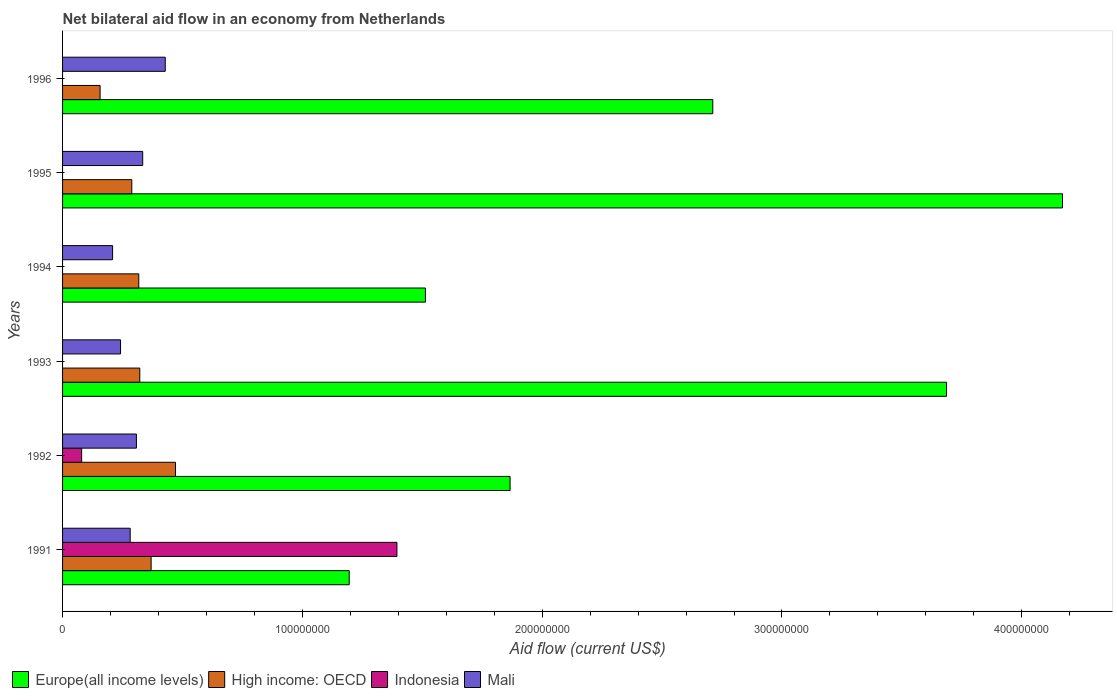How many different coloured bars are there?
Make the answer very short. 4. Are the number of bars per tick equal to the number of legend labels?
Give a very brief answer. No. Are the number of bars on each tick of the Y-axis equal?
Give a very brief answer. No. What is the net bilateral aid flow in Mali in 1992?
Offer a very short reply. 3.08e+07. Across all years, what is the maximum net bilateral aid flow in Europe(all income levels)?
Offer a very short reply. 4.17e+08. In which year was the net bilateral aid flow in Mali maximum?
Give a very brief answer. 1996. What is the total net bilateral aid flow in Mali in the graph?
Provide a short and direct response. 1.80e+08. What is the difference between the net bilateral aid flow in High income: OECD in 1992 and that in 1994?
Offer a terse response. 1.53e+07. What is the difference between the net bilateral aid flow in Mali in 1992 and the net bilateral aid flow in Europe(all income levels) in 1991?
Ensure brevity in your answer.  -8.87e+07. What is the average net bilateral aid flow in Indonesia per year?
Offer a terse response. 2.46e+07. In the year 1996, what is the difference between the net bilateral aid flow in High income: OECD and net bilateral aid flow in Europe(all income levels)?
Give a very brief answer. -2.56e+08. In how many years, is the net bilateral aid flow in Europe(all income levels) greater than 180000000 US$?
Provide a short and direct response. 4. What is the ratio of the net bilateral aid flow in Mali in 1991 to that in 1996?
Keep it short and to the point. 0.66. Is the difference between the net bilateral aid flow in High income: OECD in 1995 and 1996 greater than the difference between the net bilateral aid flow in Europe(all income levels) in 1995 and 1996?
Your answer should be compact. No. What is the difference between the highest and the second highest net bilateral aid flow in Europe(all income levels)?
Make the answer very short. 4.84e+07. What is the difference between the highest and the lowest net bilateral aid flow in High income: OECD?
Make the answer very short. 3.14e+07. In how many years, is the net bilateral aid flow in Indonesia greater than the average net bilateral aid flow in Indonesia taken over all years?
Make the answer very short. 1. Is the sum of the net bilateral aid flow in High income: OECD in 1991 and 1992 greater than the maximum net bilateral aid flow in Europe(all income levels) across all years?
Ensure brevity in your answer.  No. Is it the case that in every year, the sum of the net bilateral aid flow in Indonesia and net bilateral aid flow in Mali is greater than the net bilateral aid flow in High income: OECD?
Your answer should be very brief. No. How many bars are there?
Offer a terse response. 20. Are all the bars in the graph horizontal?
Your response must be concise. Yes. Does the graph contain grids?
Your answer should be compact. No. How many legend labels are there?
Make the answer very short. 4. What is the title of the graph?
Provide a short and direct response. Net bilateral aid flow in an economy from Netherlands. What is the label or title of the X-axis?
Your answer should be very brief. Aid flow (current US$). What is the Aid flow (current US$) in Europe(all income levels) in 1991?
Ensure brevity in your answer.  1.20e+08. What is the Aid flow (current US$) of High income: OECD in 1991?
Your response must be concise. 3.69e+07. What is the Aid flow (current US$) in Indonesia in 1991?
Offer a very short reply. 1.39e+08. What is the Aid flow (current US$) in Mali in 1991?
Give a very brief answer. 2.82e+07. What is the Aid flow (current US$) in Europe(all income levels) in 1992?
Offer a very short reply. 1.87e+08. What is the Aid flow (current US$) of High income: OECD in 1992?
Provide a succinct answer. 4.71e+07. What is the Aid flow (current US$) in Indonesia in 1992?
Your answer should be compact. 7.96e+06. What is the Aid flow (current US$) of Mali in 1992?
Your answer should be very brief. 3.08e+07. What is the Aid flow (current US$) in Europe(all income levels) in 1993?
Offer a terse response. 3.69e+08. What is the Aid flow (current US$) of High income: OECD in 1993?
Give a very brief answer. 3.22e+07. What is the Aid flow (current US$) in Mali in 1993?
Ensure brevity in your answer.  2.42e+07. What is the Aid flow (current US$) of Europe(all income levels) in 1994?
Provide a short and direct response. 1.51e+08. What is the Aid flow (current US$) of High income: OECD in 1994?
Ensure brevity in your answer.  3.18e+07. What is the Aid flow (current US$) in Indonesia in 1994?
Give a very brief answer. 0. What is the Aid flow (current US$) of Mali in 1994?
Offer a very short reply. 2.09e+07. What is the Aid flow (current US$) of Europe(all income levels) in 1995?
Provide a short and direct response. 4.17e+08. What is the Aid flow (current US$) in High income: OECD in 1995?
Provide a succinct answer. 2.89e+07. What is the Aid flow (current US$) of Indonesia in 1995?
Give a very brief answer. 0. What is the Aid flow (current US$) in Mali in 1995?
Provide a succinct answer. 3.34e+07. What is the Aid flow (current US$) in Europe(all income levels) in 1996?
Your answer should be compact. 2.71e+08. What is the Aid flow (current US$) in High income: OECD in 1996?
Your answer should be compact. 1.56e+07. What is the Aid flow (current US$) of Indonesia in 1996?
Your response must be concise. 0. What is the Aid flow (current US$) of Mali in 1996?
Your answer should be very brief. 4.28e+07. Across all years, what is the maximum Aid flow (current US$) of Europe(all income levels)?
Offer a very short reply. 4.17e+08. Across all years, what is the maximum Aid flow (current US$) of High income: OECD?
Make the answer very short. 4.71e+07. Across all years, what is the maximum Aid flow (current US$) in Indonesia?
Your response must be concise. 1.39e+08. Across all years, what is the maximum Aid flow (current US$) in Mali?
Keep it short and to the point. 4.28e+07. Across all years, what is the minimum Aid flow (current US$) in Europe(all income levels)?
Provide a short and direct response. 1.20e+08. Across all years, what is the minimum Aid flow (current US$) in High income: OECD?
Give a very brief answer. 1.56e+07. Across all years, what is the minimum Aid flow (current US$) in Indonesia?
Keep it short and to the point. 0. Across all years, what is the minimum Aid flow (current US$) of Mali?
Your answer should be compact. 2.09e+07. What is the total Aid flow (current US$) in Europe(all income levels) in the graph?
Your response must be concise. 1.51e+09. What is the total Aid flow (current US$) in High income: OECD in the graph?
Keep it short and to the point. 1.93e+08. What is the total Aid flow (current US$) in Indonesia in the graph?
Provide a succinct answer. 1.47e+08. What is the total Aid flow (current US$) in Mali in the graph?
Give a very brief answer. 1.80e+08. What is the difference between the Aid flow (current US$) in Europe(all income levels) in 1991 and that in 1992?
Give a very brief answer. -6.71e+07. What is the difference between the Aid flow (current US$) in High income: OECD in 1991 and that in 1992?
Your answer should be very brief. -1.02e+07. What is the difference between the Aid flow (current US$) of Indonesia in 1991 and that in 1992?
Give a very brief answer. 1.31e+08. What is the difference between the Aid flow (current US$) of Mali in 1991 and that in 1992?
Your answer should be compact. -2.60e+06. What is the difference between the Aid flow (current US$) of Europe(all income levels) in 1991 and that in 1993?
Your response must be concise. -2.49e+08. What is the difference between the Aid flow (current US$) of High income: OECD in 1991 and that in 1993?
Keep it short and to the point. 4.72e+06. What is the difference between the Aid flow (current US$) of Mali in 1991 and that in 1993?
Offer a terse response. 4.02e+06. What is the difference between the Aid flow (current US$) of Europe(all income levels) in 1991 and that in 1994?
Your response must be concise. -3.18e+07. What is the difference between the Aid flow (current US$) of High income: OECD in 1991 and that in 1994?
Keep it short and to the point. 5.15e+06. What is the difference between the Aid flow (current US$) of Mali in 1991 and that in 1994?
Provide a short and direct response. 7.34e+06. What is the difference between the Aid flow (current US$) in Europe(all income levels) in 1991 and that in 1995?
Your answer should be compact. -2.97e+08. What is the difference between the Aid flow (current US$) in High income: OECD in 1991 and that in 1995?
Provide a short and direct response. 8.06e+06. What is the difference between the Aid flow (current US$) of Mali in 1991 and that in 1995?
Give a very brief answer. -5.22e+06. What is the difference between the Aid flow (current US$) in Europe(all income levels) in 1991 and that in 1996?
Provide a succinct answer. -1.52e+08. What is the difference between the Aid flow (current US$) of High income: OECD in 1991 and that in 1996?
Ensure brevity in your answer.  2.13e+07. What is the difference between the Aid flow (current US$) in Mali in 1991 and that in 1996?
Offer a very short reply. -1.46e+07. What is the difference between the Aid flow (current US$) of Europe(all income levels) in 1992 and that in 1993?
Your answer should be compact. -1.82e+08. What is the difference between the Aid flow (current US$) in High income: OECD in 1992 and that in 1993?
Offer a very short reply. 1.49e+07. What is the difference between the Aid flow (current US$) of Mali in 1992 and that in 1993?
Make the answer very short. 6.62e+06. What is the difference between the Aid flow (current US$) in Europe(all income levels) in 1992 and that in 1994?
Your answer should be compact. 3.53e+07. What is the difference between the Aid flow (current US$) in High income: OECD in 1992 and that in 1994?
Ensure brevity in your answer.  1.53e+07. What is the difference between the Aid flow (current US$) of Mali in 1992 and that in 1994?
Your answer should be very brief. 9.94e+06. What is the difference between the Aid flow (current US$) of Europe(all income levels) in 1992 and that in 1995?
Your answer should be compact. -2.30e+08. What is the difference between the Aid flow (current US$) in High income: OECD in 1992 and that in 1995?
Offer a very short reply. 1.82e+07. What is the difference between the Aid flow (current US$) in Mali in 1992 and that in 1995?
Ensure brevity in your answer.  -2.62e+06. What is the difference between the Aid flow (current US$) in Europe(all income levels) in 1992 and that in 1996?
Provide a short and direct response. -8.45e+07. What is the difference between the Aid flow (current US$) of High income: OECD in 1992 and that in 1996?
Ensure brevity in your answer.  3.14e+07. What is the difference between the Aid flow (current US$) in Mali in 1992 and that in 1996?
Provide a succinct answer. -1.20e+07. What is the difference between the Aid flow (current US$) in Europe(all income levels) in 1993 and that in 1994?
Offer a very short reply. 2.17e+08. What is the difference between the Aid flow (current US$) in High income: OECD in 1993 and that in 1994?
Offer a very short reply. 4.30e+05. What is the difference between the Aid flow (current US$) of Mali in 1993 and that in 1994?
Your answer should be compact. 3.32e+06. What is the difference between the Aid flow (current US$) in Europe(all income levels) in 1993 and that in 1995?
Your answer should be compact. -4.84e+07. What is the difference between the Aid flow (current US$) of High income: OECD in 1993 and that in 1995?
Your answer should be very brief. 3.34e+06. What is the difference between the Aid flow (current US$) of Mali in 1993 and that in 1995?
Provide a succinct answer. -9.24e+06. What is the difference between the Aid flow (current US$) in Europe(all income levels) in 1993 and that in 1996?
Your response must be concise. 9.75e+07. What is the difference between the Aid flow (current US$) in High income: OECD in 1993 and that in 1996?
Your answer should be very brief. 1.66e+07. What is the difference between the Aid flow (current US$) in Mali in 1993 and that in 1996?
Make the answer very short. -1.86e+07. What is the difference between the Aid flow (current US$) in Europe(all income levels) in 1994 and that in 1995?
Offer a very short reply. -2.66e+08. What is the difference between the Aid flow (current US$) in High income: OECD in 1994 and that in 1995?
Provide a short and direct response. 2.91e+06. What is the difference between the Aid flow (current US$) in Mali in 1994 and that in 1995?
Give a very brief answer. -1.26e+07. What is the difference between the Aid flow (current US$) of Europe(all income levels) in 1994 and that in 1996?
Ensure brevity in your answer.  -1.20e+08. What is the difference between the Aid flow (current US$) of High income: OECD in 1994 and that in 1996?
Provide a short and direct response. 1.61e+07. What is the difference between the Aid flow (current US$) of Mali in 1994 and that in 1996?
Make the answer very short. -2.20e+07. What is the difference between the Aid flow (current US$) in Europe(all income levels) in 1995 and that in 1996?
Provide a succinct answer. 1.46e+08. What is the difference between the Aid flow (current US$) of High income: OECD in 1995 and that in 1996?
Give a very brief answer. 1.32e+07. What is the difference between the Aid flow (current US$) in Mali in 1995 and that in 1996?
Your answer should be very brief. -9.40e+06. What is the difference between the Aid flow (current US$) of Europe(all income levels) in 1991 and the Aid flow (current US$) of High income: OECD in 1992?
Keep it short and to the point. 7.24e+07. What is the difference between the Aid flow (current US$) of Europe(all income levels) in 1991 and the Aid flow (current US$) of Indonesia in 1992?
Provide a short and direct response. 1.12e+08. What is the difference between the Aid flow (current US$) in Europe(all income levels) in 1991 and the Aid flow (current US$) in Mali in 1992?
Your answer should be very brief. 8.87e+07. What is the difference between the Aid flow (current US$) of High income: OECD in 1991 and the Aid flow (current US$) of Indonesia in 1992?
Provide a short and direct response. 2.90e+07. What is the difference between the Aid flow (current US$) of High income: OECD in 1991 and the Aid flow (current US$) of Mali in 1992?
Make the answer very short. 6.13e+06. What is the difference between the Aid flow (current US$) in Indonesia in 1991 and the Aid flow (current US$) in Mali in 1992?
Provide a succinct answer. 1.09e+08. What is the difference between the Aid flow (current US$) in Europe(all income levels) in 1991 and the Aid flow (current US$) in High income: OECD in 1993?
Make the answer very short. 8.73e+07. What is the difference between the Aid flow (current US$) in Europe(all income levels) in 1991 and the Aid flow (current US$) in Mali in 1993?
Make the answer very short. 9.54e+07. What is the difference between the Aid flow (current US$) of High income: OECD in 1991 and the Aid flow (current US$) of Mali in 1993?
Provide a succinct answer. 1.28e+07. What is the difference between the Aid flow (current US$) of Indonesia in 1991 and the Aid flow (current US$) of Mali in 1993?
Make the answer very short. 1.15e+08. What is the difference between the Aid flow (current US$) in Europe(all income levels) in 1991 and the Aid flow (current US$) in High income: OECD in 1994?
Provide a short and direct response. 8.78e+07. What is the difference between the Aid flow (current US$) of Europe(all income levels) in 1991 and the Aid flow (current US$) of Mali in 1994?
Provide a short and direct response. 9.87e+07. What is the difference between the Aid flow (current US$) of High income: OECD in 1991 and the Aid flow (current US$) of Mali in 1994?
Offer a very short reply. 1.61e+07. What is the difference between the Aid flow (current US$) in Indonesia in 1991 and the Aid flow (current US$) in Mali in 1994?
Your answer should be compact. 1.19e+08. What is the difference between the Aid flow (current US$) of Europe(all income levels) in 1991 and the Aid flow (current US$) of High income: OECD in 1995?
Keep it short and to the point. 9.07e+07. What is the difference between the Aid flow (current US$) in Europe(all income levels) in 1991 and the Aid flow (current US$) in Mali in 1995?
Offer a terse response. 8.61e+07. What is the difference between the Aid flow (current US$) in High income: OECD in 1991 and the Aid flow (current US$) in Mali in 1995?
Make the answer very short. 3.51e+06. What is the difference between the Aid flow (current US$) of Indonesia in 1991 and the Aid flow (current US$) of Mali in 1995?
Your response must be concise. 1.06e+08. What is the difference between the Aid flow (current US$) in Europe(all income levels) in 1991 and the Aid flow (current US$) in High income: OECD in 1996?
Make the answer very short. 1.04e+08. What is the difference between the Aid flow (current US$) of Europe(all income levels) in 1991 and the Aid flow (current US$) of Mali in 1996?
Your answer should be very brief. 7.67e+07. What is the difference between the Aid flow (current US$) in High income: OECD in 1991 and the Aid flow (current US$) in Mali in 1996?
Your answer should be very brief. -5.89e+06. What is the difference between the Aid flow (current US$) in Indonesia in 1991 and the Aid flow (current US$) in Mali in 1996?
Ensure brevity in your answer.  9.66e+07. What is the difference between the Aid flow (current US$) in Europe(all income levels) in 1992 and the Aid flow (current US$) in High income: OECD in 1993?
Provide a short and direct response. 1.54e+08. What is the difference between the Aid flow (current US$) of Europe(all income levels) in 1992 and the Aid flow (current US$) of Mali in 1993?
Ensure brevity in your answer.  1.62e+08. What is the difference between the Aid flow (current US$) in High income: OECD in 1992 and the Aid flow (current US$) in Mali in 1993?
Provide a short and direct response. 2.29e+07. What is the difference between the Aid flow (current US$) of Indonesia in 1992 and the Aid flow (current US$) of Mali in 1993?
Keep it short and to the point. -1.62e+07. What is the difference between the Aid flow (current US$) of Europe(all income levels) in 1992 and the Aid flow (current US$) of High income: OECD in 1994?
Make the answer very short. 1.55e+08. What is the difference between the Aid flow (current US$) in Europe(all income levels) in 1992 and the Aid flow (current US$) in Mali in 1994?
Provide a succinct answer. 1.66e+08. What is the difference between the Aid flow (current US$) in High income: OECD in 1992 and the Aid flow (current US$) in Mali in 1994?
Your answer should be compact. 2.62e+07. What is the difference between the Aid flow (current US$) in Indonesia in 1992 and the Aid flow (current US$) in Mali in 1994?
Provide a short and direct response. -1.29e+07. What is the difference between the Aid flow (current US$) in Europe(all income levels) in 1992 and the Aid flow (current US$) in High income: OECD in 1995?
Offer a terse response. 1.58e+08. What is the difference between the Aid flow (current US$) in Europe(all income levels) in 1992 and the Aid flow (current US$) in Mali in 1995?
Provide a succinct answer. 1.53e+08. What is the difference between the Aid flow (current US$) in High income: OECD in 1992 and the Aid flow (current US$) in Mali in 1995?
Offer a terse response. 1.37e+07. What is the difference between the Aid flow (current US$) of Indonesia in 1992 and the Aid flow (current US$) of Mali in 1995?
Your answer should be very brief. -2.55e+07. What is the difference between the Aid flow (current US$) in Europe(all income levels) in 1992 and the Aid flow (current US$) in High income: OECD in 1996?
Provide a short and direct response. 1.71e+08. What is the difference between the Aid flow (current US$) in Europe(all income levels) in 1992 and the Aid flow (current US$) in Mali in 1996?
Provide a short and direct response. 1.44e+08. What is the difference between the Aid flow (current US$) in High income: OECD in 1992 and the Aid flow (current US$) in Mali in 1996?
Your response must be concise. 4.28e+06. What is the difference between the Aid flow (current US$) in Indonesia in 1992 and the Aid flow (current US$) in Mali in 1996?
Offer a terse response. -3.49e+07. What is the difference between the Aid flow (current US$) in Europe(all income levels) in 1993 and the Aid flow (current US$) in High income: OECD in 1994?
Offer a terse response. 3.37e+08. What is the difference between the Aid flow (current US$) in Europe(all income levels) in 1993 and the Aid flow (current US$) in Mali in 1994?
Your answer should be compact. 3.48e+08. What is the difference between the Aid flow (current US$) of High income: OECD in 1993 and the Aid flow (current US$) of Mali in 1994?
Provide a short and direct response. 1.14e+07. What is the difference between the Aid flow (current US$) in Europe(all income levels) in 1993 and the Aid flow (current US$) in High income: OECD in 1995?
Provide a succinct answer. 3.40e+08. What is the difference between the Aid flow (current US$) in Europe(all income levels) in 1993 and the Aid flow (current US$) in Mali in 1995?
Keep it short and to the point. 3.35e+08. What is the difference between the Aid flow (current US$) in High income: OECD in 1993 and the Aid flow (current US$) in Mali in 1995?
Your response must be concise. -1.21e+06. What is the difference between the Aid flow (current US$) in Europe(all income levels) in 1993 and the Aid flow (current US$) in High income: OECD in 1996?
Provide a short and direct response. 3.53e+08. What is the difference between the Aid flow (current US$) of Europe(all income levels) in 1993 and the Aid flow (current US$) of Mali in 1996?
Your answer should be compact. 3.26e+08. What is the difference between the Aid flow (current US$) in High income: OECD in 1993 and the Aid flow (current US$) in Mali in 1996?
Your answer should be very brief. -1.06e+07. What is the difference between the Aid flow (current US$) of Europe(all income levels) in 1994 and the Aid flow (current US$) of High income: OECD in 1995?
Your answer should be very brief. 1.22e+08. What is the difference between the Aid flow (current US$) in Europe(all income levels) in 1994 and the Aid flow (current US$) in Mali in 1995?
Provide a short and direct response. 1.18e+08. What is the difference between the Aid flow (current US$) of High income: OECD in 1994 and the Aid flow (current US$) of Mali in 1995?
Your answer should be very brief. -1.64e+06. What is the difference between the Aid flow (current US$) in Europe(all income levels) in 1994 and the Aid flow (current US$) in High income: OECD in 1996?
Offer a terse response. 1.36e+08. What is the difference between the Aid flow (current US$) of Europe(all income levels) in 1994 and the Aid flow (current US$) of Mali in 1996?
Provide a succinct answer. 1.08e+08. What is the difference between the Aid flow (current US$) in High income: OECD in 1994 and the Aid flow (current US$) in Mali in 1996?
Make the answer very short. -1.10e+07. What is the difference between the Aid flow (current US$) in Europe(all income levels) in 1995 and the Aid flow (current US$) in High income: OECD in 1996?
Keep it short and to the point. 4.01e+08. What is the difference between the Aid flow (current US$) of Europe(all income levels) in 1995 and the Aid flow (current US$) of Mali in 1996?
Keep it short and to the point. 3.74e+08. What is the difference between the Aid flow (current US$) of High income: OECD in 1995 and the Aid flow (current US$) of Mali in 1996?
Your response must be concise. -1.40e+07. What is the average Aid flow (current US$) of Europe(all income levels) per year?
Your response must be concise. 2.52e+08. What is the average Aid flow (current US$) in High income: OECD per year?
Ensure brevity in your answer.  3.21e+07. What is the average Aid flow (current US$) of Indonesia per year?
Ensure brevity in your answer.  2.46e+07. What is the average Aid flow (current US$) in Mali per year?
Offer a terse response. 3.00e+07. In the year 1991, what is the difference between the Aid flow (current US$) of Europe(all income levels) and Aid flow (current US$) of High income: OECD?
Your response must be concise. 8.26e+07. In the year 1991, what is the difference between the Aid flow (current US$) of Europe(all income levels) and Aid flow (current US$) of Indonesia?
Provide a short and direct response. -1.99e+07. In the year 1991, what is the difference between the Aid flow (current US$) of Europe(all income levels) and Aid flow (current US$) of Mali?
Make the answer very short. 9.13e+07. In the year 1991, what is the difference between the Aid flow (current US$) in High income: OECD and Aid flow (current US$) in Indonesia?
Give a very brief answer. -1.03e+08. In the year 1991, what is the difference between the Aid flow (current US$) of High income: OECD and Aid flow (current US$) of Mali?
Ensure brevity in your answer.  8.73e+06. In the year 1991, what is the difference between the Aid flow (current US$) in Indonesia and Aid flow (current US$) in Mali?
Offer a very short reply. 1.11e+08. In the year 1992, what is the difference between the Aid flow (current US$) in Europe(all income levels) and Aid flow (current US$) in High income: OECD?
Your answer should be very brief. 1.40e+08. In the year 1992, what is the difference between the Aid flow (current US$) in Europe(all income levels) and Aid flow (current US$) in Indonesia?
Ensure brevity in your answer.  1.79e+08. In the year 1992, what is the difference between the Aid flow (current US$) in Europe(all income levels) and Aid flow (current US$) in Mali?
Provide a succinct answer. 1.56e+08. In the year 1992, what is the difference between the Aid flow (current US$) of High income: OECD and Aid flow (current US$) of Indonesia?
Give a very brief answer. 3.91e+07. In the year 1992, what is the difference between the Aid flow (current US$) in High income: OECD and Aid flow (current US$) in Mali?
Your answer should be very brief. 1.63e+07. In the year 1992, what is the difference between the Aid flow (current US$) of Indonesia and Aid flow (current US$) of Mali?
Offer a very short reply. -2.28e+07. In the year 1993, what is the difference between the Aid flow (current US$) of Europe(all income levels) and Aid flow (current US$) of High income: OECD?
Make the answer very short. 3.36e+08. In the year 1993, what is the difference between the Aid flow (current US$) in Europe(all income levels) and Aid flow (current US$) in Mali?
Your answer should be compact. 3.44e+08. In the year 1993, what is the difference between the Aid flow (current US$) in High income: OECD and Aid flow (current US$) in Mali?
Your response must be concise. 8.03e+06. In the year 1994, what is the difference between the Aid flow (current US$) in Europe(all income levels) and Aid flow (current US$) in High income: OECD?
Your response must be concise. 1.20e+08. In the year 1994, what is the difference between the Aid flow (current US$) of Europe(all income levels) and Aid flow (current US$) of Mali?
Give a very brief answer. 1.30e+08. In the year 1994, what is the difference between the Aid flow (current US$) of High income: OECD and Aid flow (current US$) of Mali?
Offer a very short reply. 1.09e+07. In the year 1995, what is the difference between the Aid flow (current US$) in Europe(all income levels) and Aid flow (current US$) in High income: OECD?
Your answer should be compact. 3.88e+08. In the year 1995, what is the difference between the Aid flow (current US$) of Europe(all income levels) and Aid flow (current US$) of Mali?
Your answer should be compact. 3.84e+08. In the year 1995, what is the difference between the Aid flow (current US$) of High income: OECD and Aid flow (current US$) of Mali?
Provide a succinct answer. -4.55e+06. In the year 1996, what is the difference between the Aid flow (current US$) of Europe(all income levels) and Aid flow (current US$) of High income: OECD?
Provide a succinct answer. 2.56e+08. In the year 1996, what is the difference between the Aid flow (current US$) of Europe(all income levels) and Aid flow (current US$) of Mali?
Provide a succinct answer. 2.28e+08. In the year 1996, what is the difference between the Aid flow (current US$) of High income: OECD and Aid flow (current US$) of Mali?
Your response must be concise. -2.72e+07. What is the ratio of the Aid flow (current US$) of Europe(all income levels) in 1991 to that in 1992?
Provide a short and direct response. 0.64. What is the ratio of the Aid flow (current US$) in High income: OECD in 1991 to that in 1992?
Your answer should be compact. 0.78. What is the ratio of the Aid flow (current US$) of Indonesia in 1991 to that in 1992?
Provide a succinct answer. 17.52. What is the ratio of the Aid flow (current US$) of Mali in 1991 to that in 1992?
Provide a short and direct response. 0.92. What is the ratio of the Aid flow (current US$) of Europe(all income levels) in 1991 to that in 1993?
Keep it short and to the point. 0.32. What is the ratio of the Aid flow (current US$) in High income: OECD in 1991 to that in 1993?
Offer a terse response. 1.15. What is the ratio of the Aid flow (current US$) in Mali in 1991 to that in 1993?
Your response must be concise. 1.17. What is the ratio of the Aid flow (current US$) of Europe(all income levels) in 1991 to that in 1994?
Provide a short and direct response. 0.79. What is the ratio of the Aid flow (current US$) in High income: OECD in 1991 to that in 1994?
Your answer should be very brief. 1.16. What is the ratio of the Aid flow (current US$) of Mali in 1991 to that in 1994?
Ensure brevity in your answer.  1.35. What is the ratio of the Aid flow (current US$) of Europe(all income levels) in 1991 to that in 1995?
Make the answer very short. 0.29. What is the ratio of the Aid flow (current US$) of High income: OECD in 1991 to that in 1995?
Your response must be concise. 1.28. What is the ratio of the Aid flow (current US$) in Mali in 1991 to that in 1995?
Your answer should be compact. 0.84. What is the ratio of the Aid flow (current US$) of Europe(all income levels) in 1991 to that in 1996?
Your answer should be very brief. 0.44. What is the ratio of the Aid flow (current US$) of High income: OECD in 1991 to that in 1996?
Make the answer very short. 2.36. What is the ratio of the Aid flow (current US$) of Mali in 1991 to that in 1996?
Your answer should be very brief. 0.66. What is the ratio of the Aid flow (current US$) of Europe(all income levels) in 1992 to that in 1993?
Your answer should be compact. 0.51. What is the ratio of the Aid flow (current US$) in High income: OECD in 1992 to that in 1993?
Give a very brief answer. 1.46. What is the ratio of the Aid flow (current US$) in Mali in 1992 to that in 1993?
Give a very brief answer. 1.27. What is the ratio of the Aid flow (current US$) of Europe(all income levels) in 1992 to that in 1994?
Ensure brevity in your answer.  1.23. What is the ratio of the Aid flow (current US$) of High income: OECD in 1992 to that in 1994?
Make the answer very short. 1.48. What is the ratio of the Aid flow (current US$) of Mali in 1992 to that in 1994?
Provide a short and direct response. 1.48. What is the ratio of the Aid flow (current US$) in Europe(all income levels) in 1992 to that in 1995?
Your answer should be compact. 0.45. What is the ratio of the Aid flow (current US$) of High income: OECD in 1992 to that in 1995?
Provide a succinct answer. 1.63. What is the ratio of the Aid flow (current US$) in Mali in 1992 to that in 1995?
Keep it short and to the point. 0.92. What is the ratio of the Aid flow (current US$) of Europe(all income levels) in 1992 to that in 1996?
Make the answer very short. 0.69. What is the ratio of the Aid flow (current US$) of High income: OECD in 1992 to that in 1996?
Provide a short and direct response. 3.01. What is the ratio of the Aid flow (current US$) in Mali in 1992 to that in 1996?
Ensure brevity in your answer.  0.72. What is the ratio of the Aid flow (current US$) in Europe(all income levels) in 1993 to that in 1994?
Provide a succinct answer. 2.44. What is the ratio of the Aid flow (current US$) in High income: OECD in 1993 to that in 1994?
Keep it short and to the point. 1.01. What is the ratio of the Aid flow (current US$) in Mali in 1993 to that in 1994?
Provide a short and direct response. 1.16. What is the ratio of the Aid flow (current US$) in Europe(all income levels) in 1993 to that in 1995?
Provide a short and direct response. 0.88. What is the ratio of the Aid flow (current US$) of High income: OECD in 1993 to that in 1995?
Your answer should be very brief. 1.12. What is the ratio of the Aid flow (current US$) of Mali in 1993 to that in 1995?
Ensure brevity in your answer.  0.72. What is the ratio of the Aid flow (current US$) of Europe(all income levels) in 1993 to that in 1996?
Provide a succinct answer. 1.36. What is the ratio of the Aid flow (current US$) in High income: OECD in 1993 to that in 1996?
Make the answer very short. 2.06. What is the ratio of the Aid flow (current US$) of Mali in 1993 to that in 1996?
Offer a terse response. 0.56. What is the ratio of the Aid flow (current US$) of Europe(all income levels) in 1994 to that in 1995?
Make the answer very short. 0.36. What is the ratio of the Aid flow (current US$) in High income: OECD in 1994 to that in 1995?
Keep it short and to the point. 1.1. What is the ratio of the Aid flow (current US$) of Mali in 1994 to that in 1995?
Your response must be concise. 0.62. What is the ratio of the Aid flow (current US$) of Europe(all income levels) in 1994 to that in 1996?
Provide a succinct answer. 0.56. What is the ratio of the Aid flow (current US$) in High income: OECD in 1994 to that in 1996?
Make the answer very short. 2.03. What is the ratio of the Aid flow (current US$) in Mali in 1994 to that in 1996?
Offer a terse response. 0.49. What is the ratio of the Aid flow (current US$) of Europe(all income levels) in 1995 to that in 1996?
Offer a very short reply. 1.54. What is the ratio of the Aid flow (current US$) of High income: OECD in 1995 to that in 1996?
Your response must be concise. 1.84. What is the ratio of the Aid flow (current US$) of Mali in 1995 to that in 1996?
Make the answer very short. 0.78. What is the difference between the highest and the second highest Aid flow (current US$) of Europe(all income levels)?
Provide a short and direct response. 4.84e+07. What is the difference between the highest and the second highest Aid flow (current US$) of High income: OECD?
Your response must be concise. 1.02e+07. What is the difference between the highest and the second highest Aid flow (current US$) in Mali?
Your answer should be very brief. 9.40e+06. What is the difference between the highest and the lowest Aid flow (current US$) in Europe(all income levels)?
Provide a short and direct response. 2.97e+08. What is the difference between the highest and the lowest Aid flow (current US$) of High income: OECD?
Make the answer very short. 3.14e+07. What is the difference between the highest and the lowest Aid flow (current US$) of Indonesia?
Keep it short and to the point. 1.39e+08. What is the difference between the highest and the lowest Aid flow (current US$) in Mali?
Offer a very short reply. 2.20e+07. 